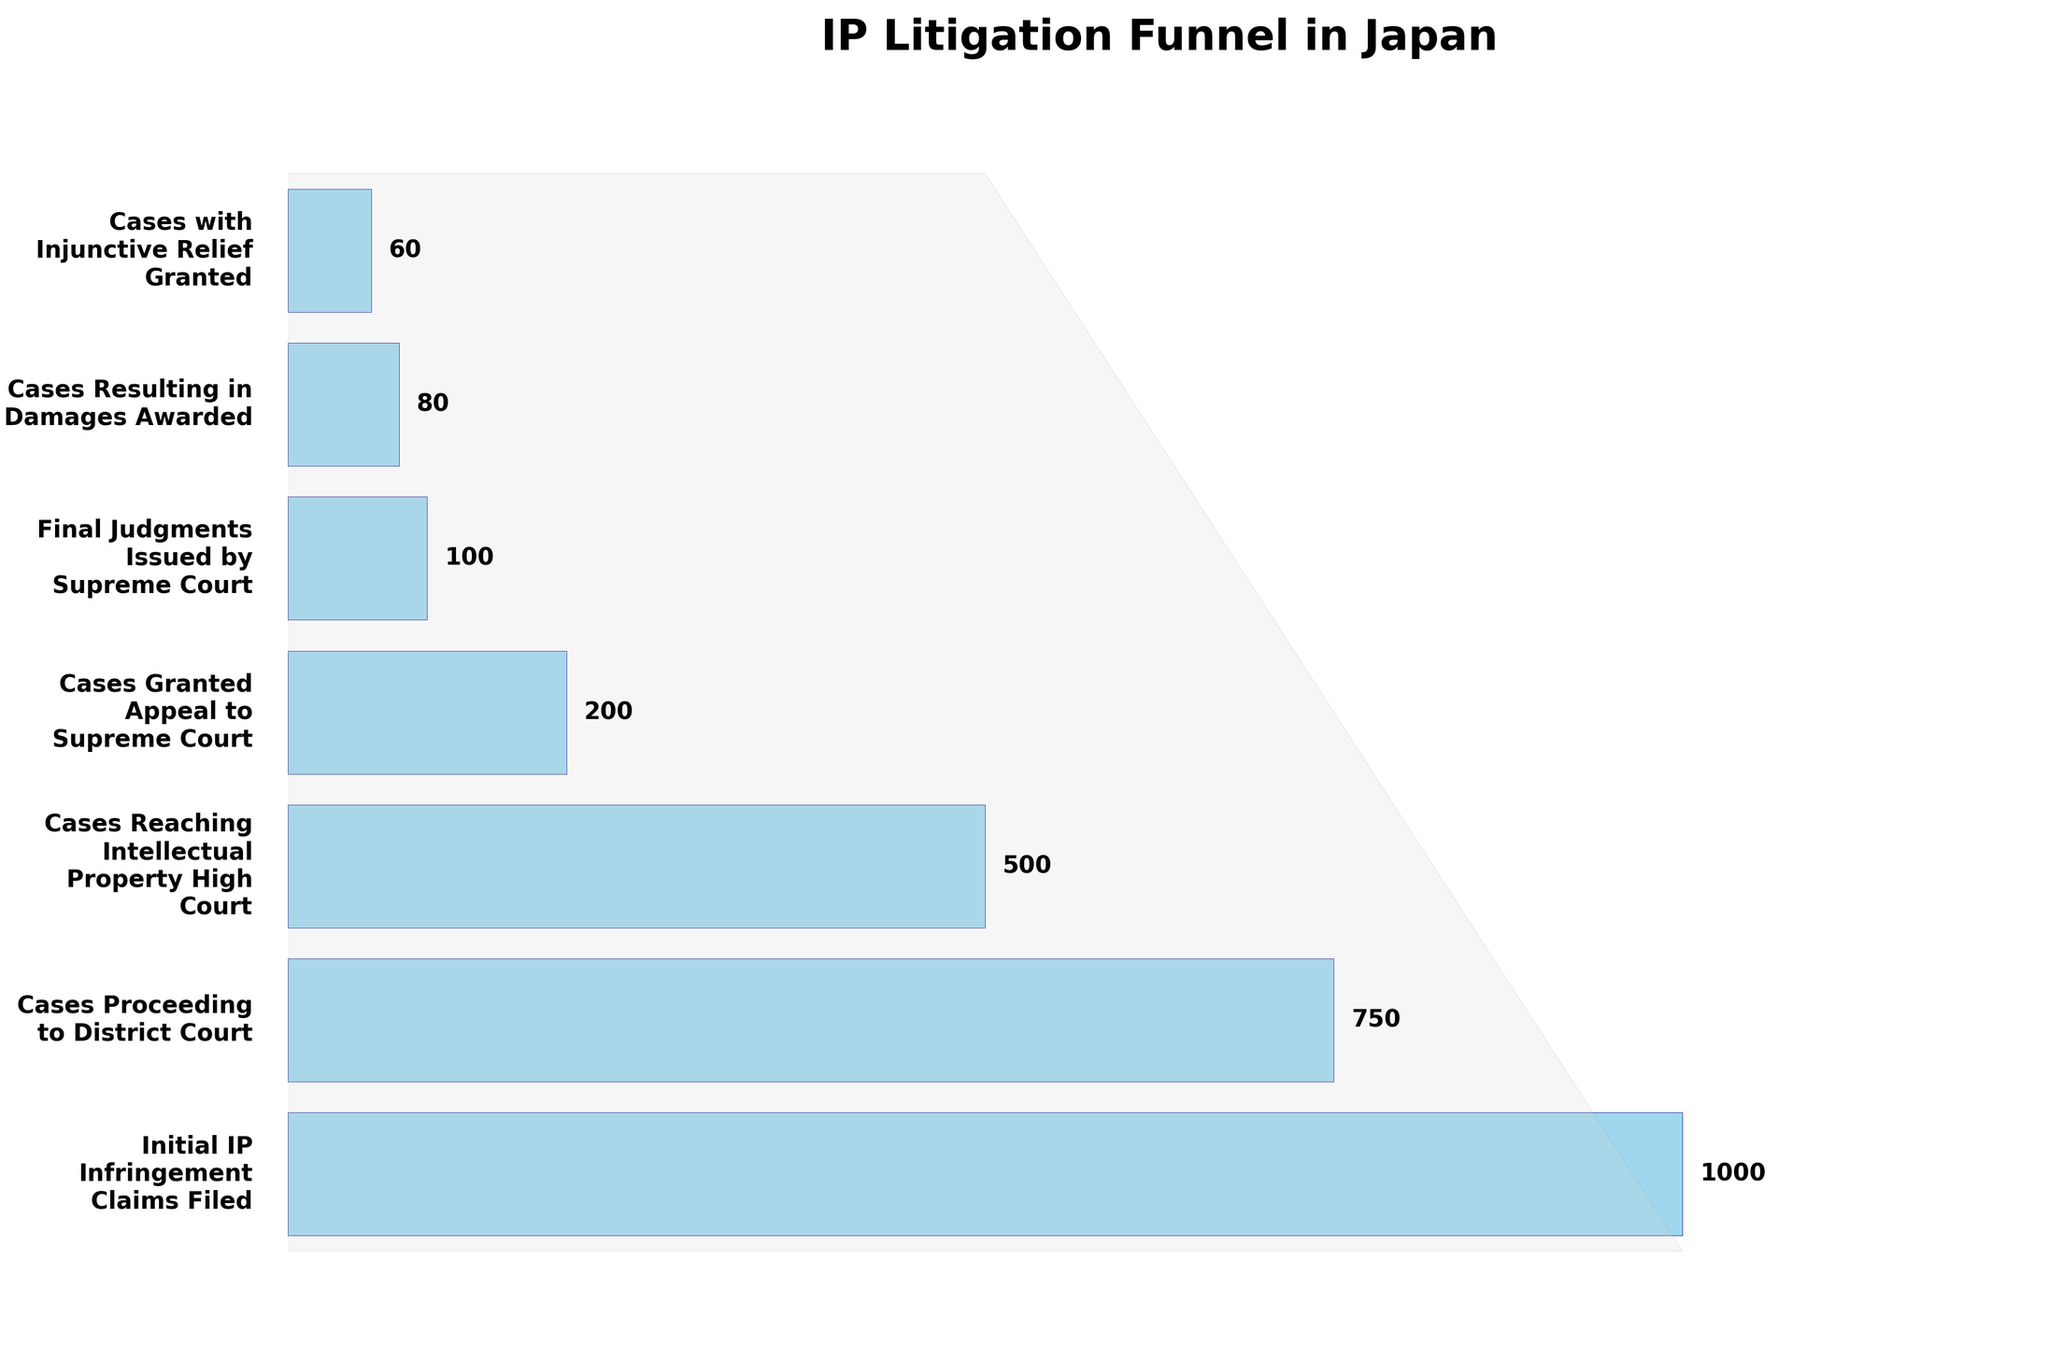What's the total number of cases that reach the Intellectual Property High Court? The number of cases that reach the Intellectual Property High Court is directly labeled in the chart. It is shown as 500 cases.
Answer: 500 Which stage has the largest decrease in the number of cases compared to the previous stage from initial filing? From the initial filings of 1000 cases down to 750 in District Court, the drop is 250 cases. The next significant drop is from 500 to 200 in Supreme Court appeals, a reduction of 300 cases. The largest decrease is from cases reaching the High Court to cases granted appeal to the Supreme Court.
Answer: Cases granted appeal to Supreme Court stage What percentage of initial IP infringement claims result in final judgments issued by the Supreme Court? There are 1000 initial claims filed and 100 final judgments issued by the Supreme Court. The percentage is (100 / 1000) * 100.
Answer: 10% Compare the number of cases resulting in damages awarded to those granted injunctive relief. Which is higher? The chart shows 80 cases resulting in damages awarded and 60 cases with injunctive relief granted. By comparing these numbers, the cases resulting in damages awarded are higher.
Answer: Cases resulting in damages awarded What stage has the fewest number of cases? By analyzing the values associated with each stage, the stage with the lowest number of cases is 'Cases with Injunctive Relief Granted,' with 60 cases.
Answer: Cases with Injunctive Relief Granted How many more cases proceed to the District Court compared to the number that reaches the Intellectual Property High Court? Cases proceeding to District Court are 750, and those reaching the High Court are 500. The difference is 750 - 500.
Answer: 250 From the initial IP infringement claims filed, what fraction of cases result in damages awarded? Starting with 1000 initial claims and ending with 80 cases resulting in damages awarded, the fraction is 80 / 1000.
Answer: 1/12.5 Calculate the attrition rate between the cases reaching the Intellectual Property High Court and the cases with final judgments issued by the Supreme Court. The cases decrease from 500 at the Intellectual Property High Court to 100 at the final judgment stage. The attrition rate is ((500 - 100) / 500) * 100.
Answer: 80% What is the difference in the number of cases between the stages of Cases Granted Appeal to Supreme Court and Final Judgments Issued by Supreme Court? Cases granted appeal to the Supreme Court are 200, and final judgments issued are 100. The difference is 200 - 100.
Answer: 100 Which stage has the highest attrition rate? To determine the stage with the highest attrition rate, calculate the drop percentage between consecutive stages. The drop from High Court cases (500) to Supreme Court appeals (200) is the largest at ((500 - 200) / 500) * 100.
Answer: Cases Granted Appeal to Supreme Court stage 